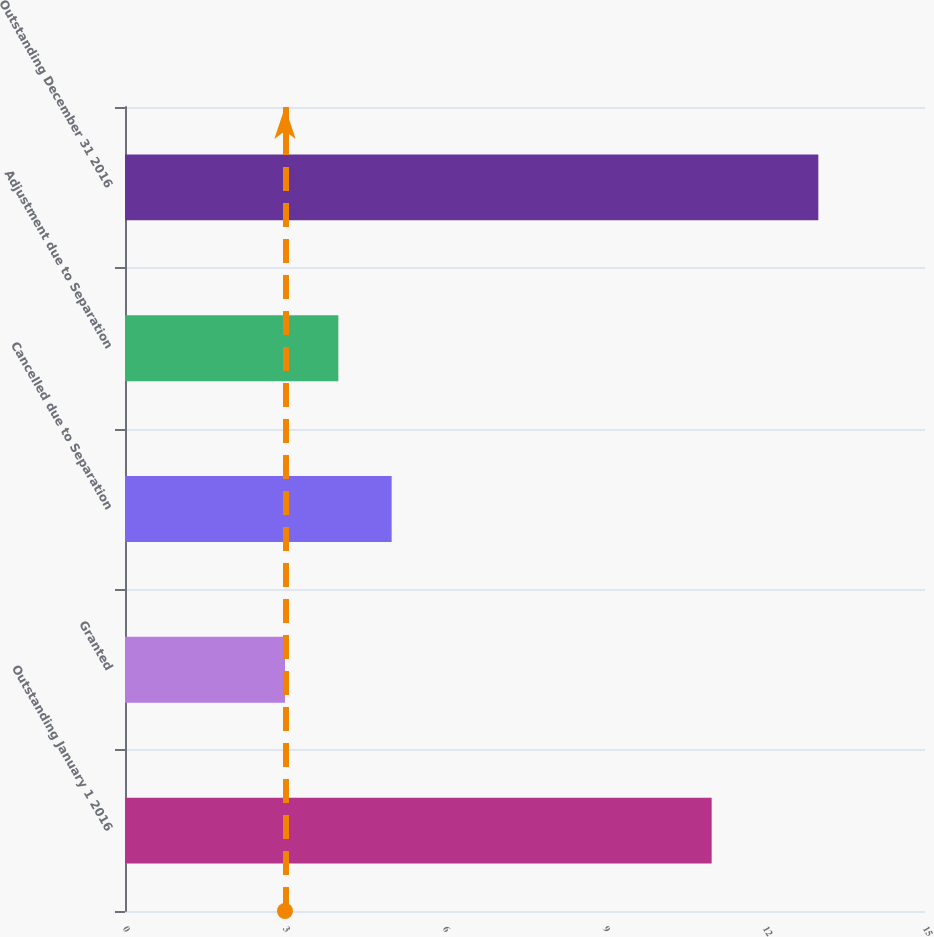<chart> <loc_0><loc_0><loc_500><loc_500><bar_chart><fcel>Outstanding January 1 2016<fcel>Granted<fcel>Cancelled due to Separation<fcel>Adjustment due to Separation<fcel>Outstanding December 31 2016<nl><fcel>11<fcel>3<fcel>5<fcel>4<fcel>13<nl></chart> 